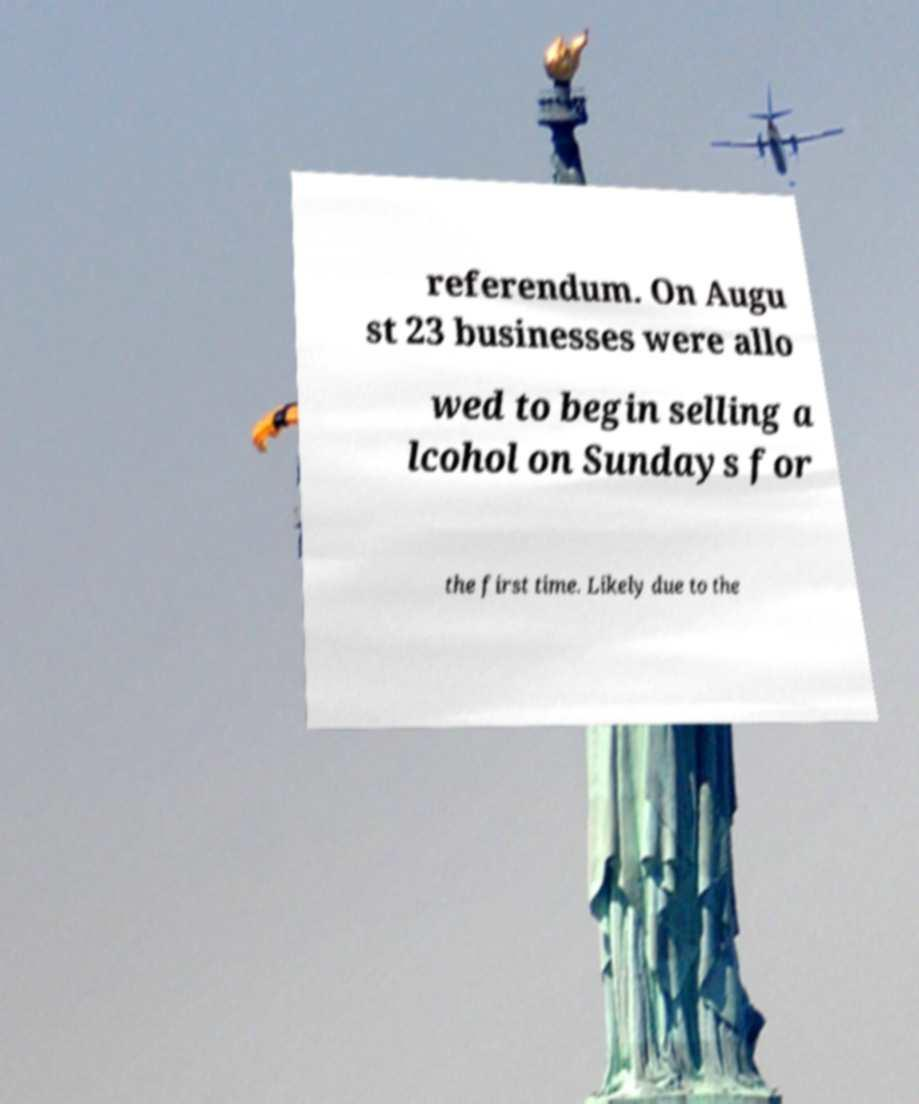Please read and relay the text visible in this image. What does it say? referendum. On Augu st 23 businesses were allo wed to begin selling a lcohol on Sundays for the first time. Likely due to the 